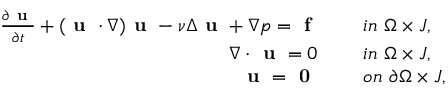Convert formula to latex. <formula><loc_0><loc_0><loc_500><loc_500>\begin{array} { r l } { \frac { \partial u } { \partial t } + ( u \cdot \nabla ) u - \nu \Delta u + \nabla p = f \quad } & { \ i n \ \Omega \times J , } \\ { \nabla \cdot u = 0 \quad } & { \ i n \ \Omega \times J , } \\ { u = 0 \quad } & { \ o n \ \partial \Omega \times J , } \end{array}</formula> 